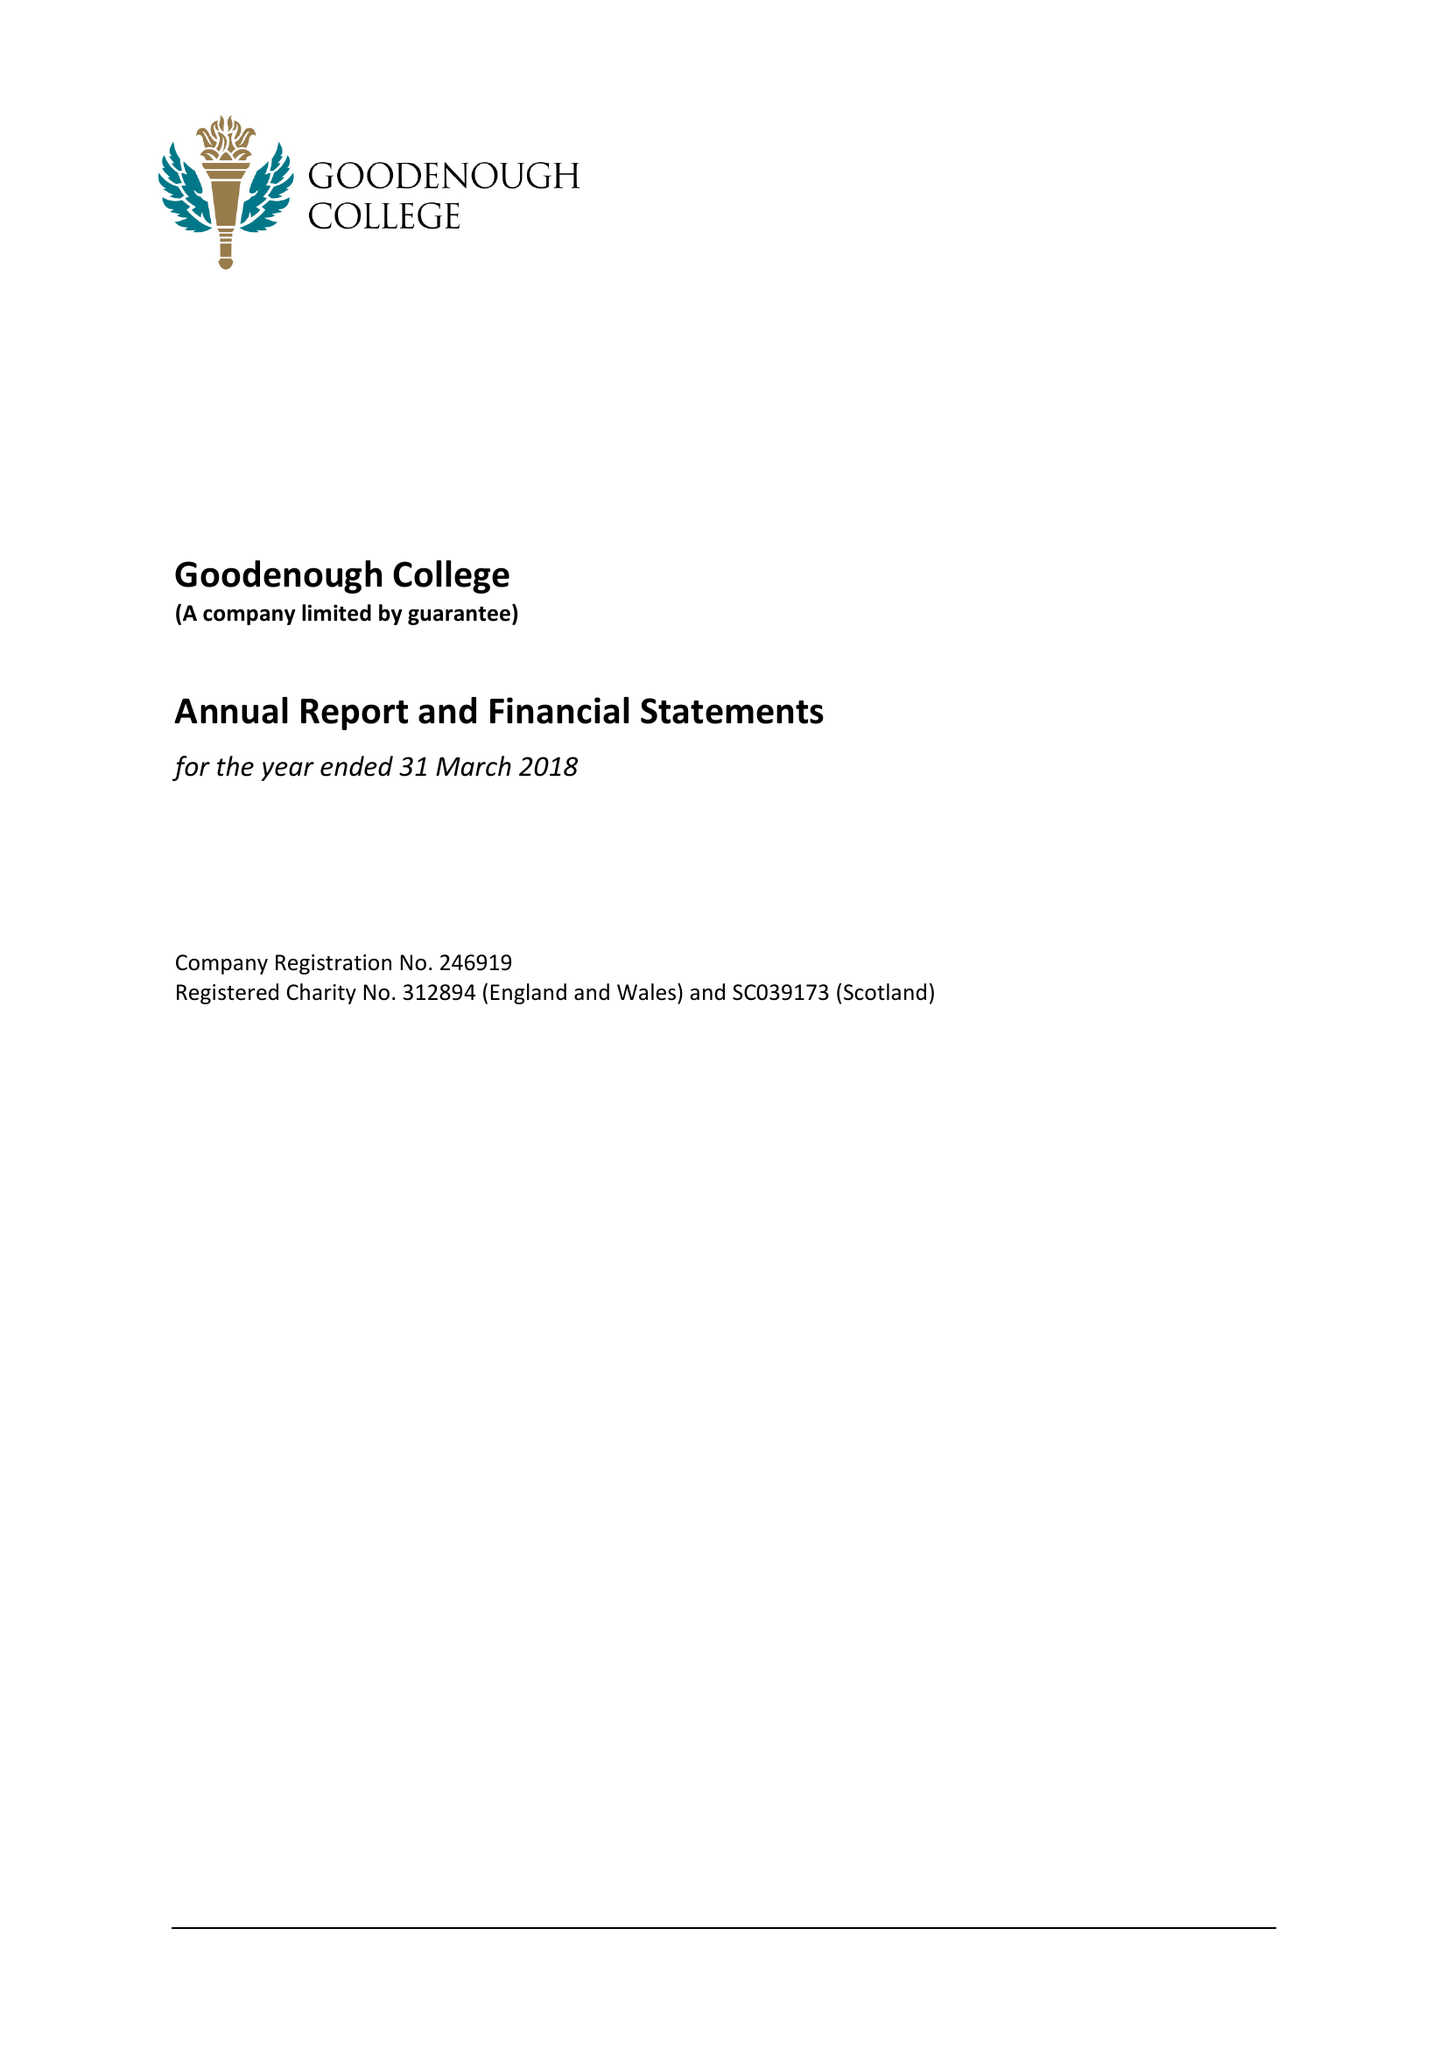What is the value for the report_date?
Answer the question using a single word or phrase. 2018-03-31 